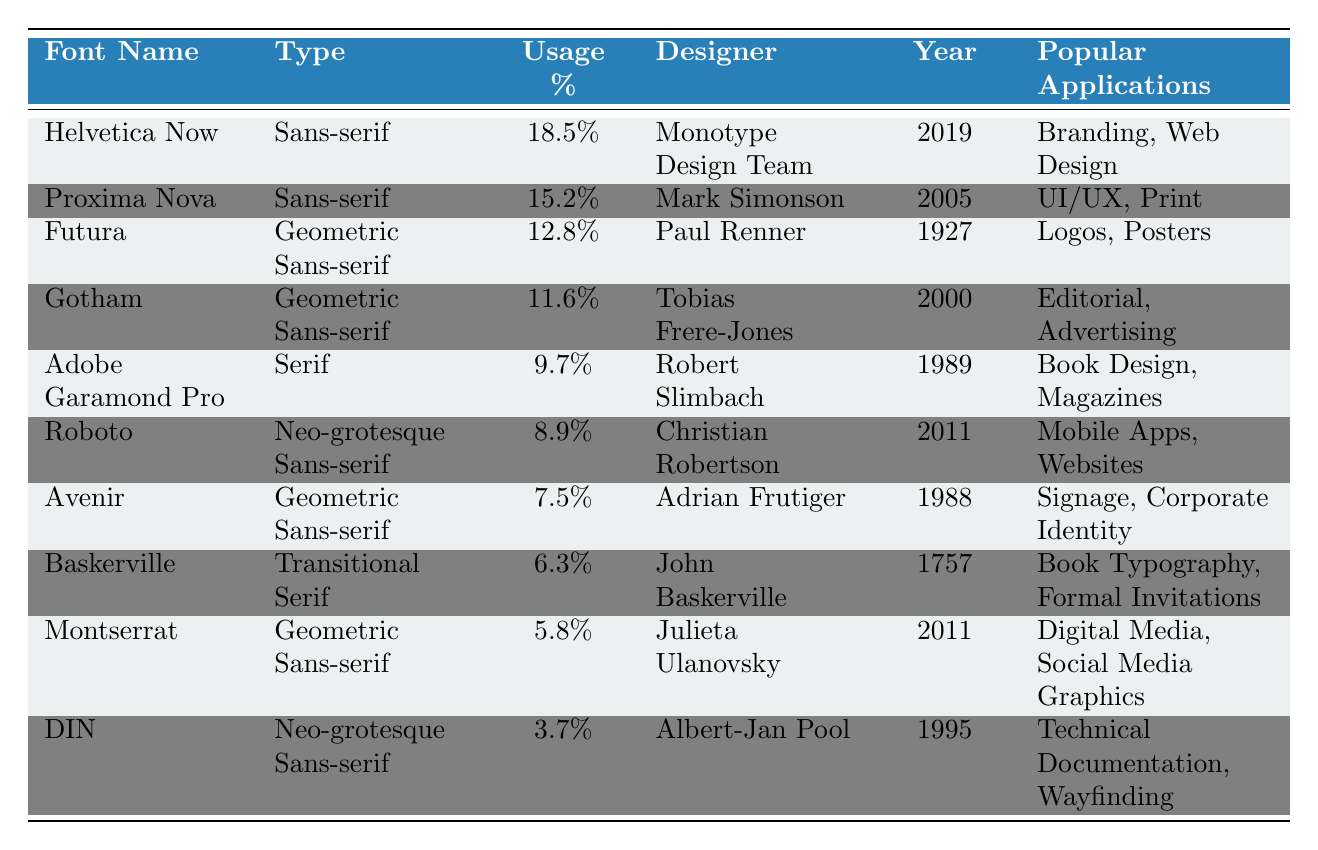What is the most used font by professional designers in 2022? By reviewing the "Usage Percentage" column, we see that "Helvetica Now" has the highest percentage at 18.5%.
Answer: Helvetica Now Which font was designed by Adrian Frutiger? The table indicates that "Avenir" was designed by Adrian Frutiger.
Answer: Avenir What is the usage percentage of "Roboto"? The "Usage Percentage" for "Roboto" is listed as 8.9%.
Answer: 8.9% How many fonts in the table were released after the year 2000? By checking the "Year Released" column, we find that there are four fonts: "Proxima Nova" (2005), "Gotham" (2000), "Roboto" (2011), and "Montserrat" (2011).
Answer: 4 Is "DIN" a serif font? Looking at the "Type" column for "DIN," it is classified as a "Neo-grotesque Sans-serif," which means it is not a serif font.
Answer: No What is the difference in usage percentage between "Helvetica Now" and "Proxima Nova"? To find this, subtract the usage percentage of "Proxima Nova" (15.2%) from "Helvetica Now" (18.5%): 18.5% - 15.2% = 3.3%.
Answer: 3.3% Which font has the lowest usage percentage in the table? Scanning the "Usage Percentage" column reveals that "DIN" has the lowest usage percentage at 3.7%.
Answer: DIN What are the popular applications for the font "Baskerville"? The "Popular Applications" column lists "Baskerville" with applications in "Book Typography, Formal Invitations."
Answer: Book Typography, Formal Invitations How many of the top fonts are classified as Geometric Sans-serif? From the table, we identify three fonts classified as Geometric Sans-serif: "Futura," "Gotham," and "Avenir."
Answer: 3 Were more fonts released in the 21st century (after 2000) than in the 20th century (1901-2000)? By counting, we find four fonts released in the 21st century ("Proxima Nova," "Roboto," "Montserrat," and "Gotham") and six in the 20th century, which shows that more fonts were released in the 20th century.
Answer: No 